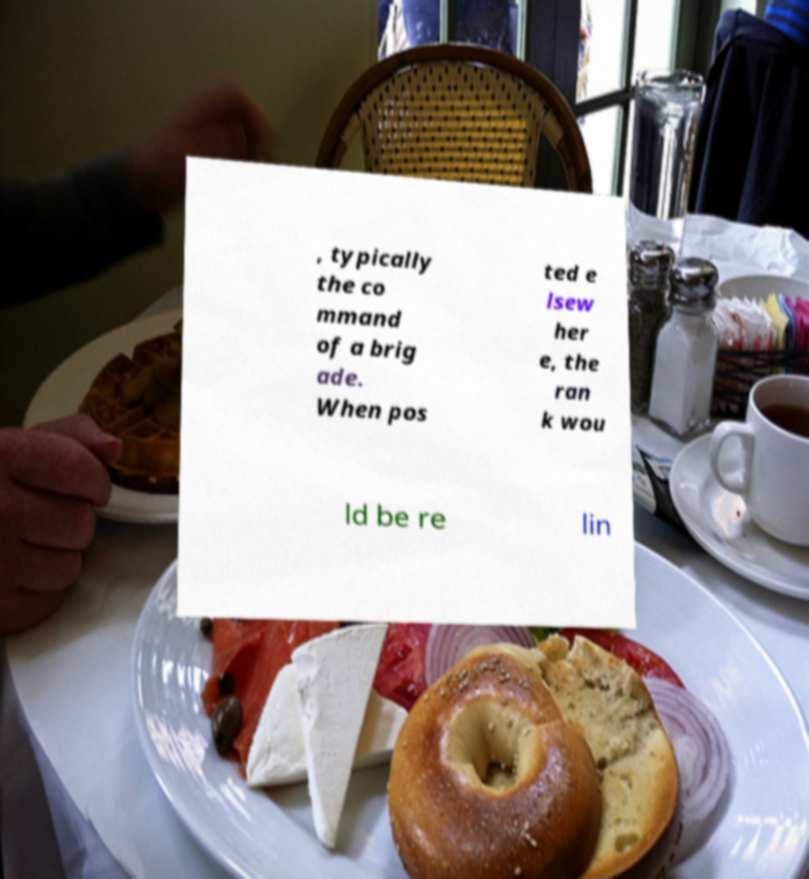Could you assist in decoding the text presented in this image and type it out clearly? , typically the co mmand of a brig ade. When pos ted e lsew her e, the ran k wou ld be re lin 